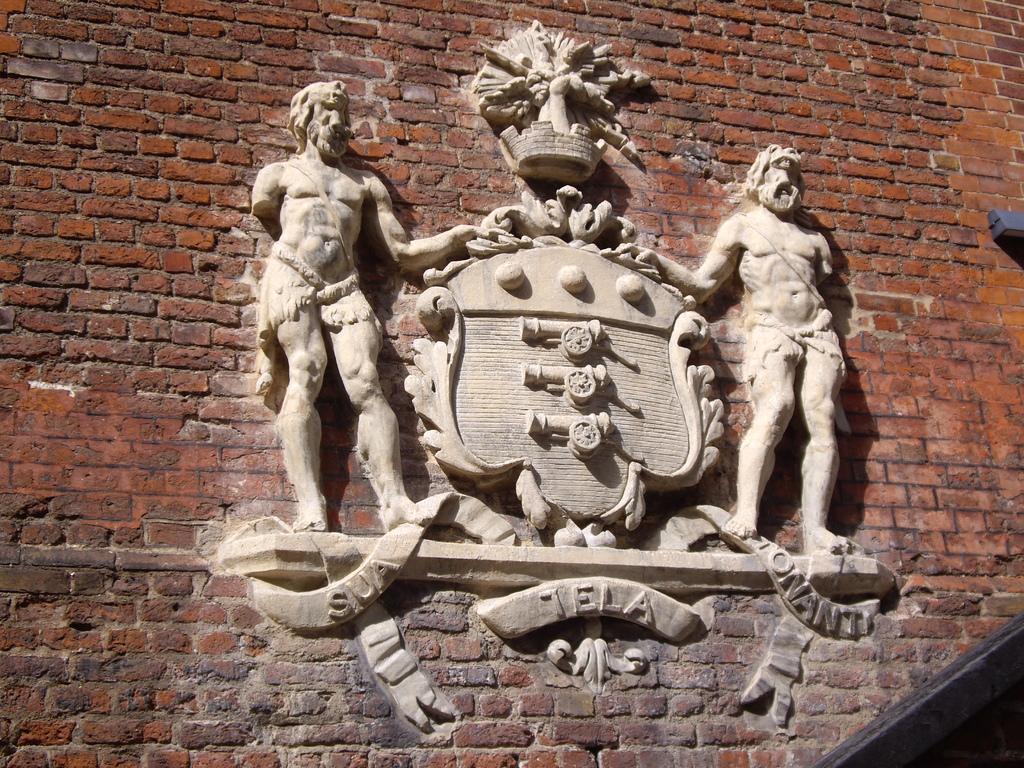Describe this image in one or two sentences. In this picture we can see a few sculptures on a brick wall. 